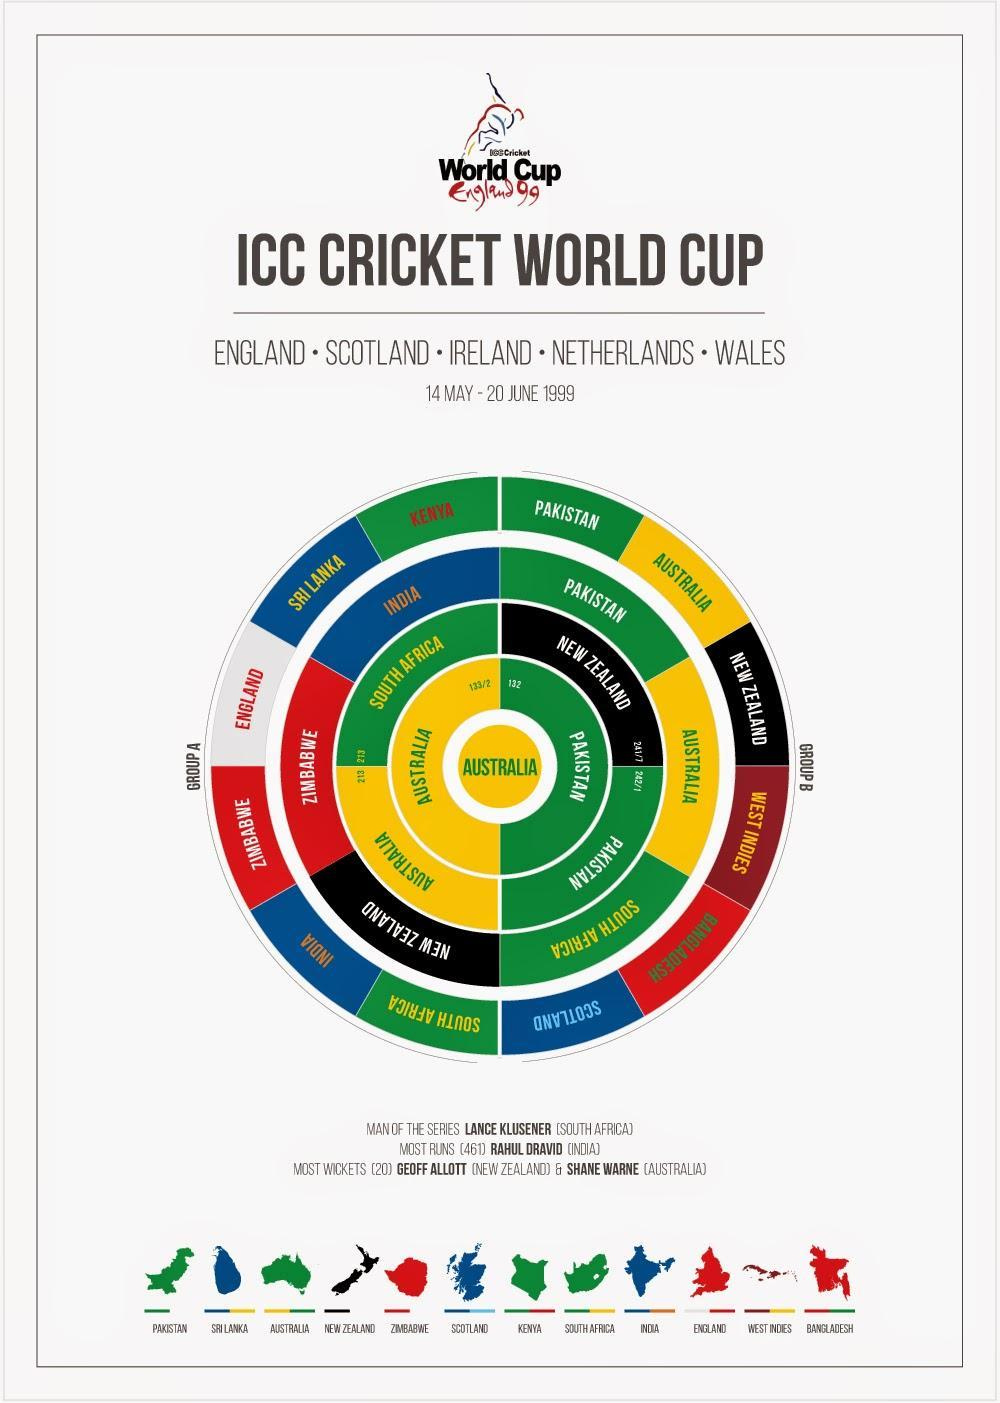What is the color code given to Team India- yellow, blue, red, green?
Answer the question with a short phrase. blue Who was the opponent of Pakistan in the semi-final? New Zealand Which Cricket team won the 1999 World Cup? Australia Who was the opponent of Australia in the semi-final? South Africa What is the color code given to Team South Africa- yellow, blue, green, black? green Which were the cricket teams who participated in the 1999 World Cup Finals? Australia, Pakistan How many teams from each group participated in the Quarters? 3 Till which level Team India reached in the 1990 World cup- Group stage, quarters, semi-finals, final? quarters How many teams qualified for the Semi-finals? 4 Who was the top scorer of the 1999 Cricket World Cup? Rahul Dravid 